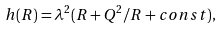Convert formula to latex. <formula><loc_0><loc_0><loc_500><loc_500>h ( R ) = \lambda ^ { 2 } ( R + Q ^ { 2 } / R + c o n s t ) ,</formula> 